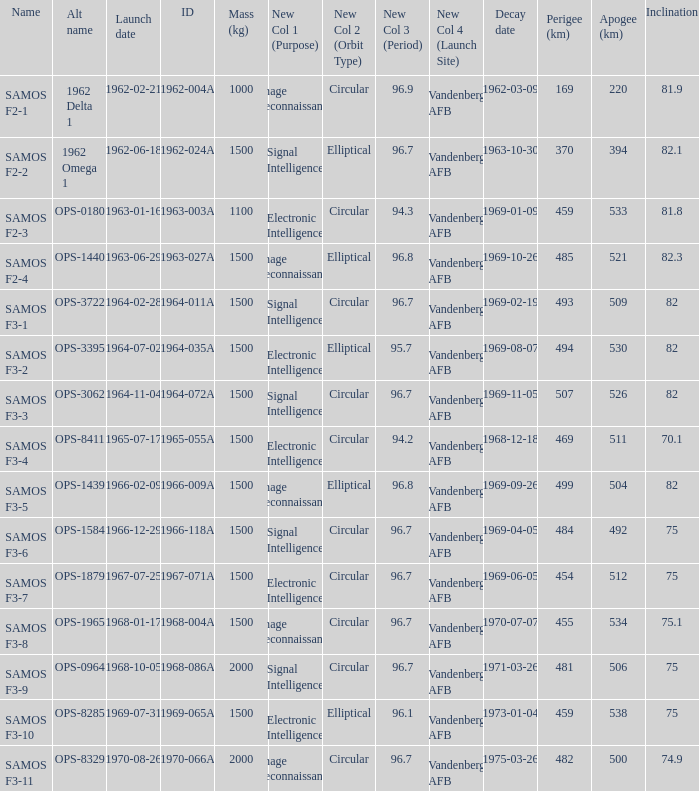How many alt names does 1964-011a have? 1.0. 